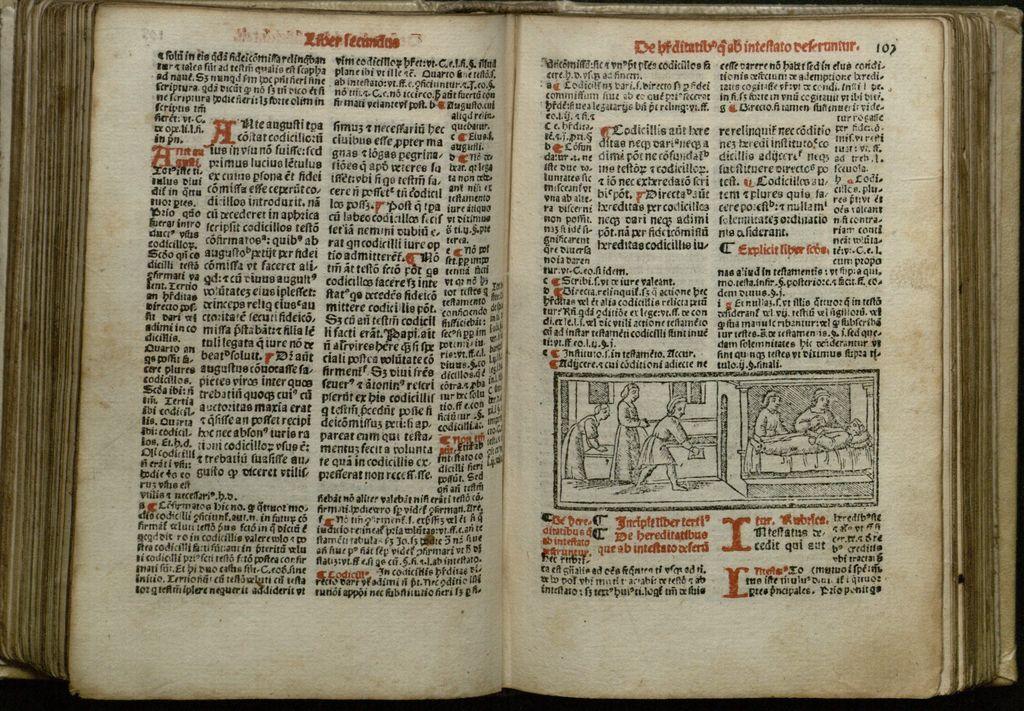What page is the rightmost page on according to the top right corner?
Your answer should be compact. 107. 